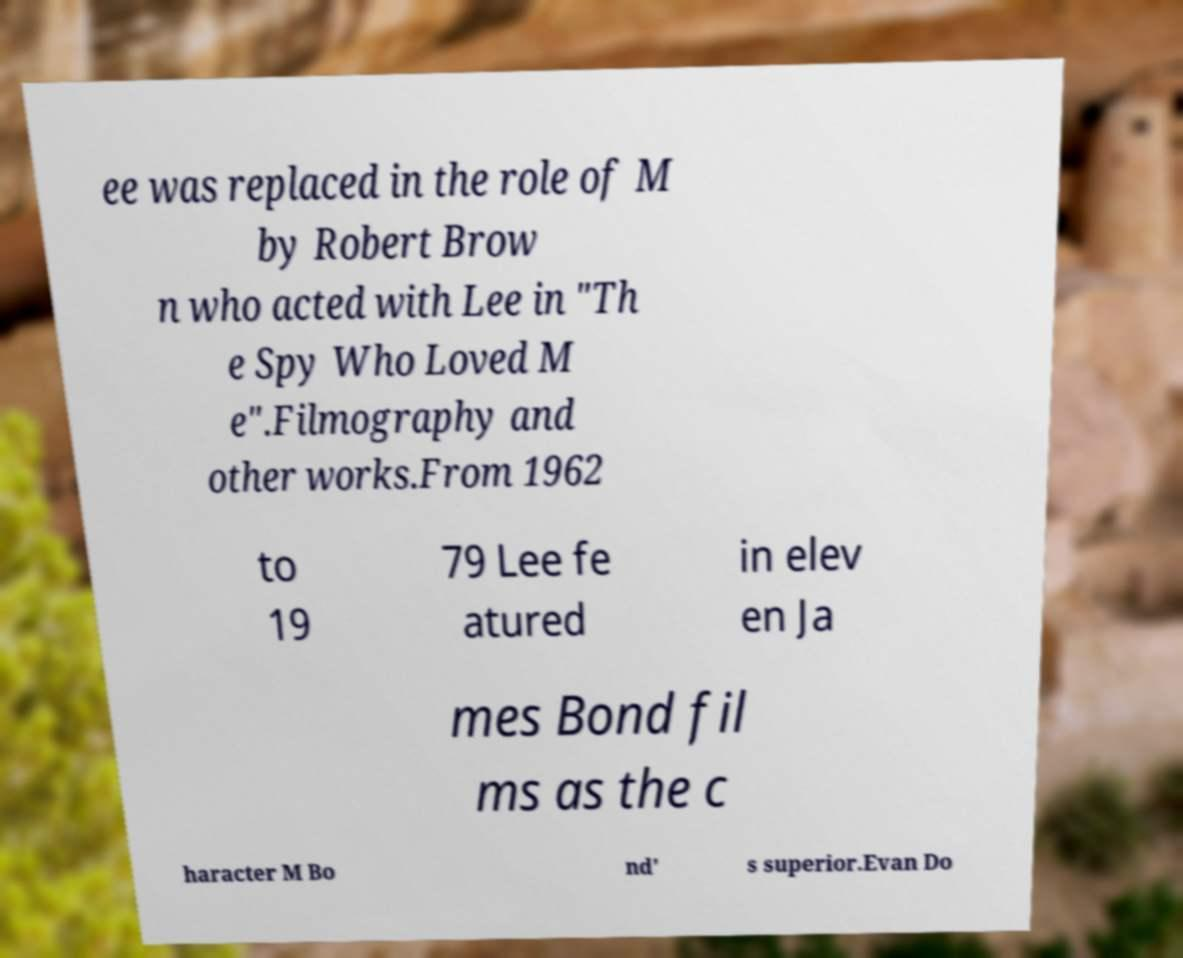Could you assist in decoding the text presented in this image and type it out clearly? ee was replaced in the role of M by Robert Brow n who acted with Lee in "Th e Spy Who Loved M e".Filmography and other works.From 1962 to 19 79 Lee fe atured in elev en Ja mes Bond fil ms as the c haracter M Bo nd' s superior.Evan Do 